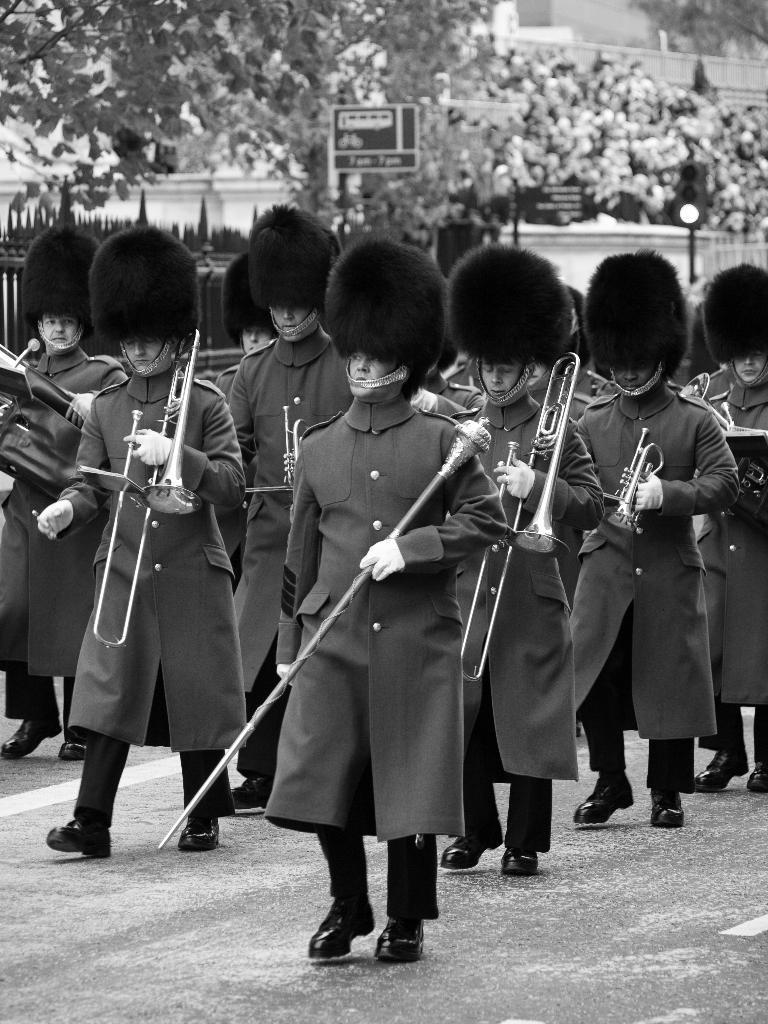Could you give a brief overview of what you see in this image? In the foreground of this black and white image, there are persons walking on the road one is holding a stick and remaining are playing trumpet and trombone. In the background, there are trees, wooden wall, traffic signal pole and a building. 